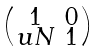<formula> <loc_0><loc_0><loc_500><loc_500>\begin{psmallmatrix} 1 & 0 \\ u N & 1 \end{psmallmatrix}</formula> 